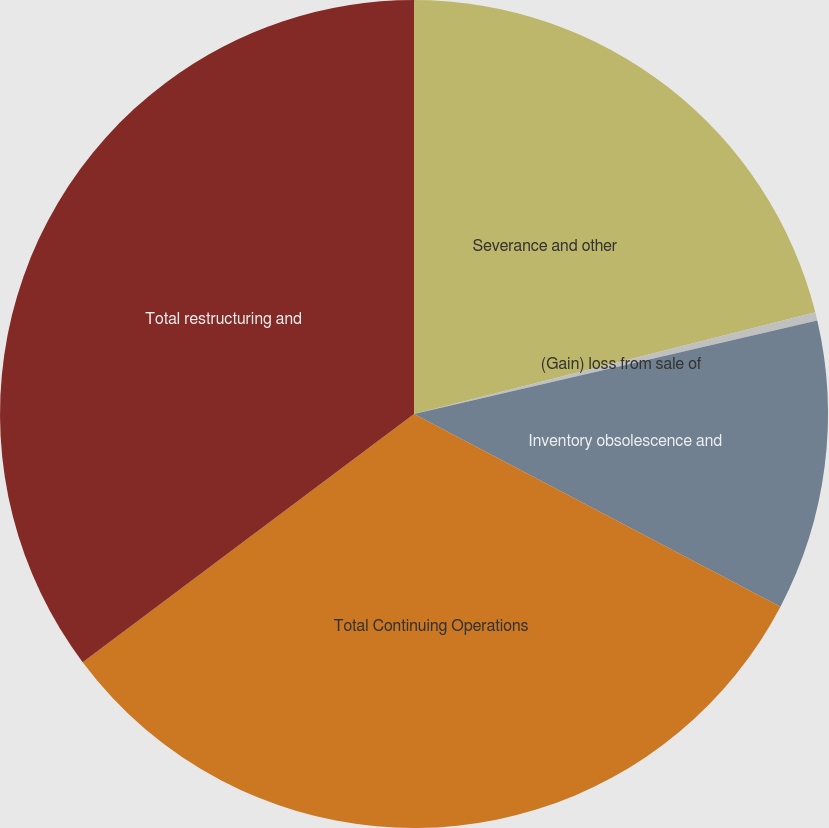Convert chart to OTSL. <chart><loc_0><loc_0><loc_500><loc_500><pie_chart><fcel>Severance and other<fcel>(Gain) loss from sale of<fcel>Inventory obsolescence and<fcel>Total Continuing Operations<fcel>Total restructuring and<nl><fcel>21.05%<fcel>0.32%<fcel>11.33%<fcel>32.06%<fcel>35.23%<nl></chart> 